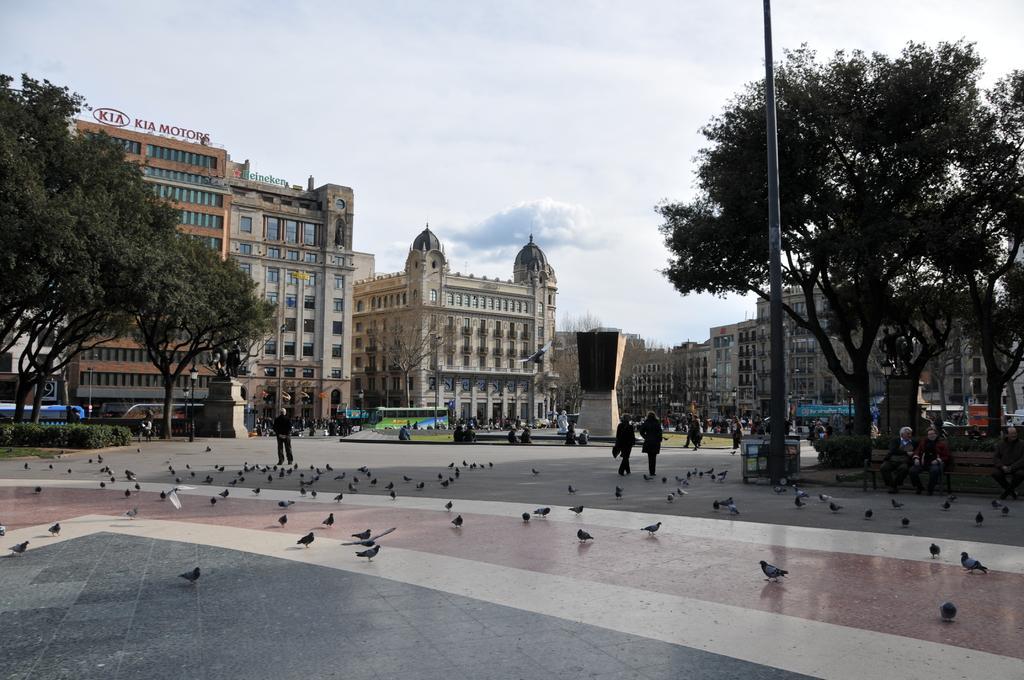Describe this image in one or two sentences. In this image we can see birds on the road, people, poles, plants, grass, vehicles, trees, buildings, lights, boards, and other objects. On the right side of the image we can see three persons are sitting on a bench. In the background there is sky with clouds. 